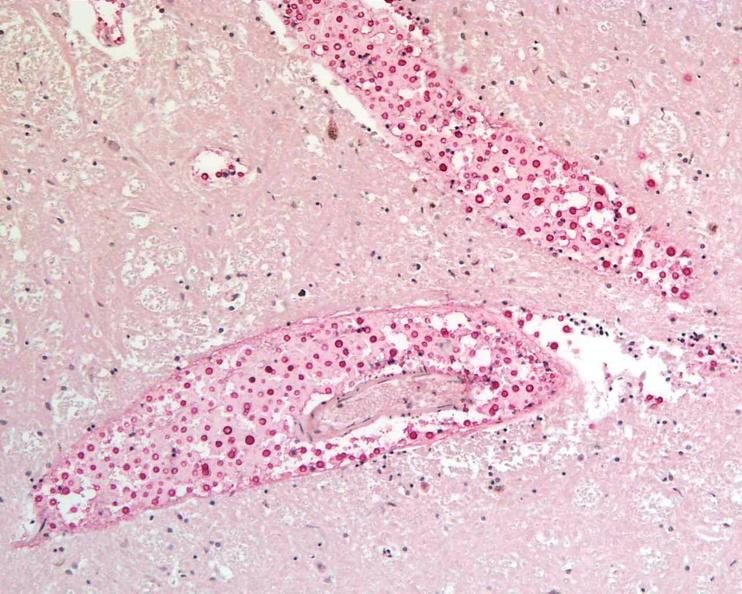what is present?
Answer the question using a single word or phrase. Nervous 